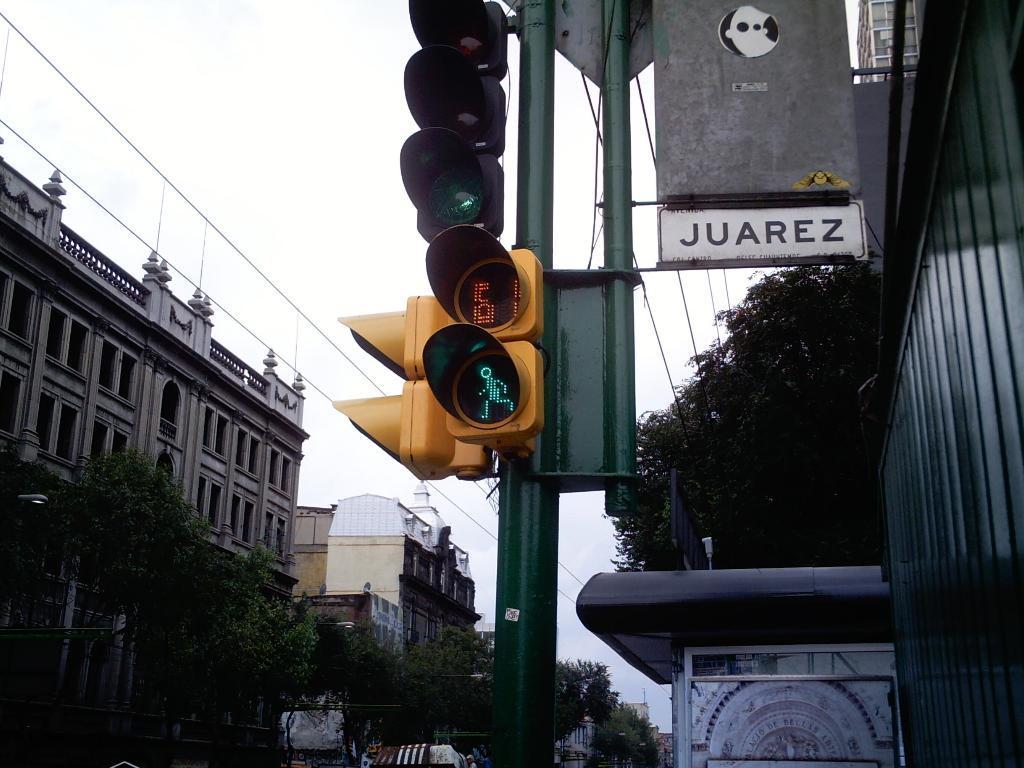Can you describe this image briefly? In this image I can see in the middle there are traffic signal lights and there are trees on either side of this image and also the buildings. At the top, it is the sky. 